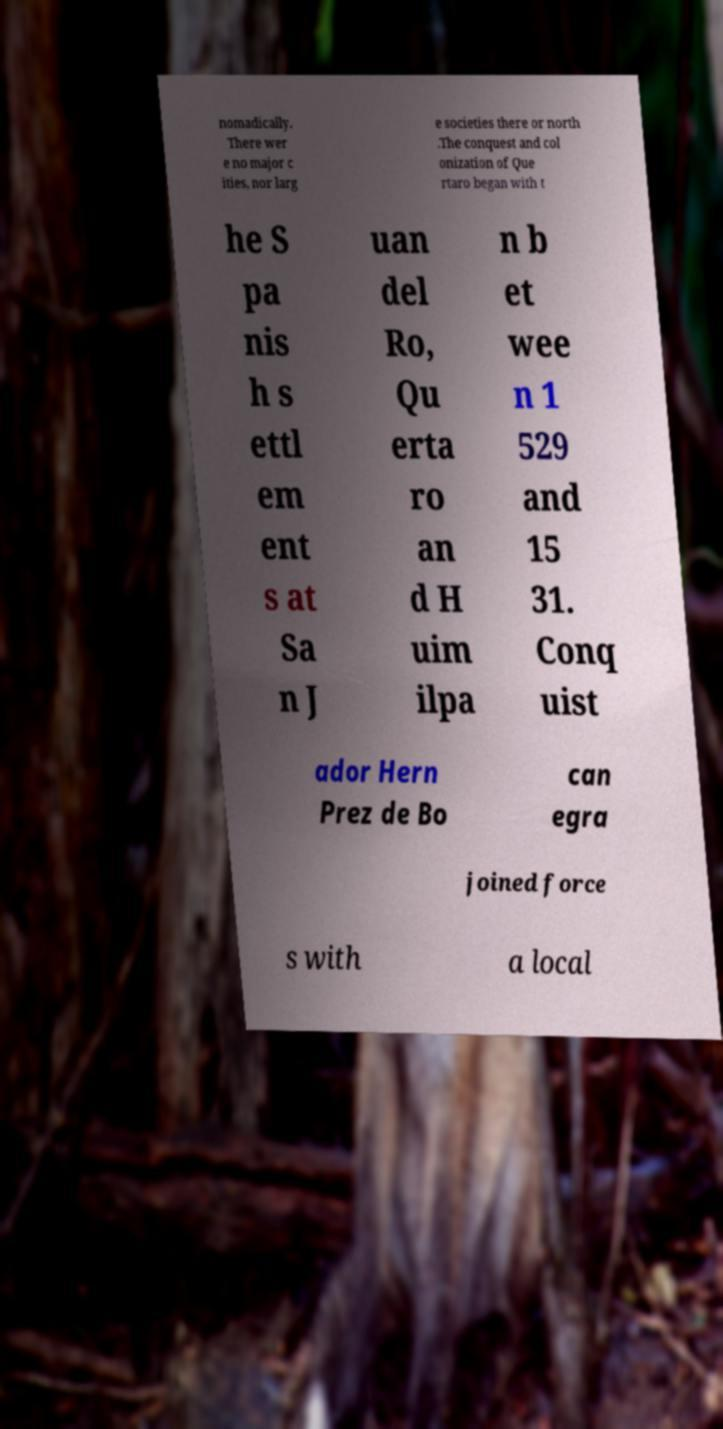Can you accurately transcribe the text from the provided image for me? nomadically. There wer e no major c ities, nor larg e societies there or north .The conquest and col onization of Que rtaro began with t he S pa nis h s ettl em ent s at Sa n J uan del Ro, Qu erta ro an d H uim ilpa n b et wee n 1 529 and 15 31. Conq uist ador Hern Prez de Bo can egra joined force s with a local 